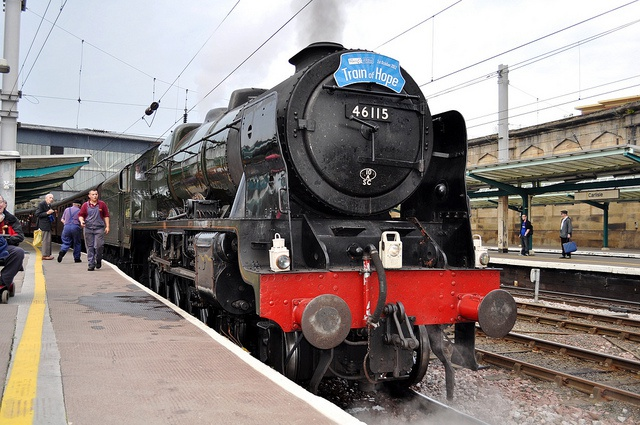Describe the objects in this image and their specific colors. I can see train in lavender, black, gray, red, and darkgray tones, people in lavender, gray, black, maroon, and purple tones, people in lavender, black, gray, navy, and darkgray tones, people in lavender, black, blue, navy, and purple tones, and people in lavender, black, and gray tones in this image. 